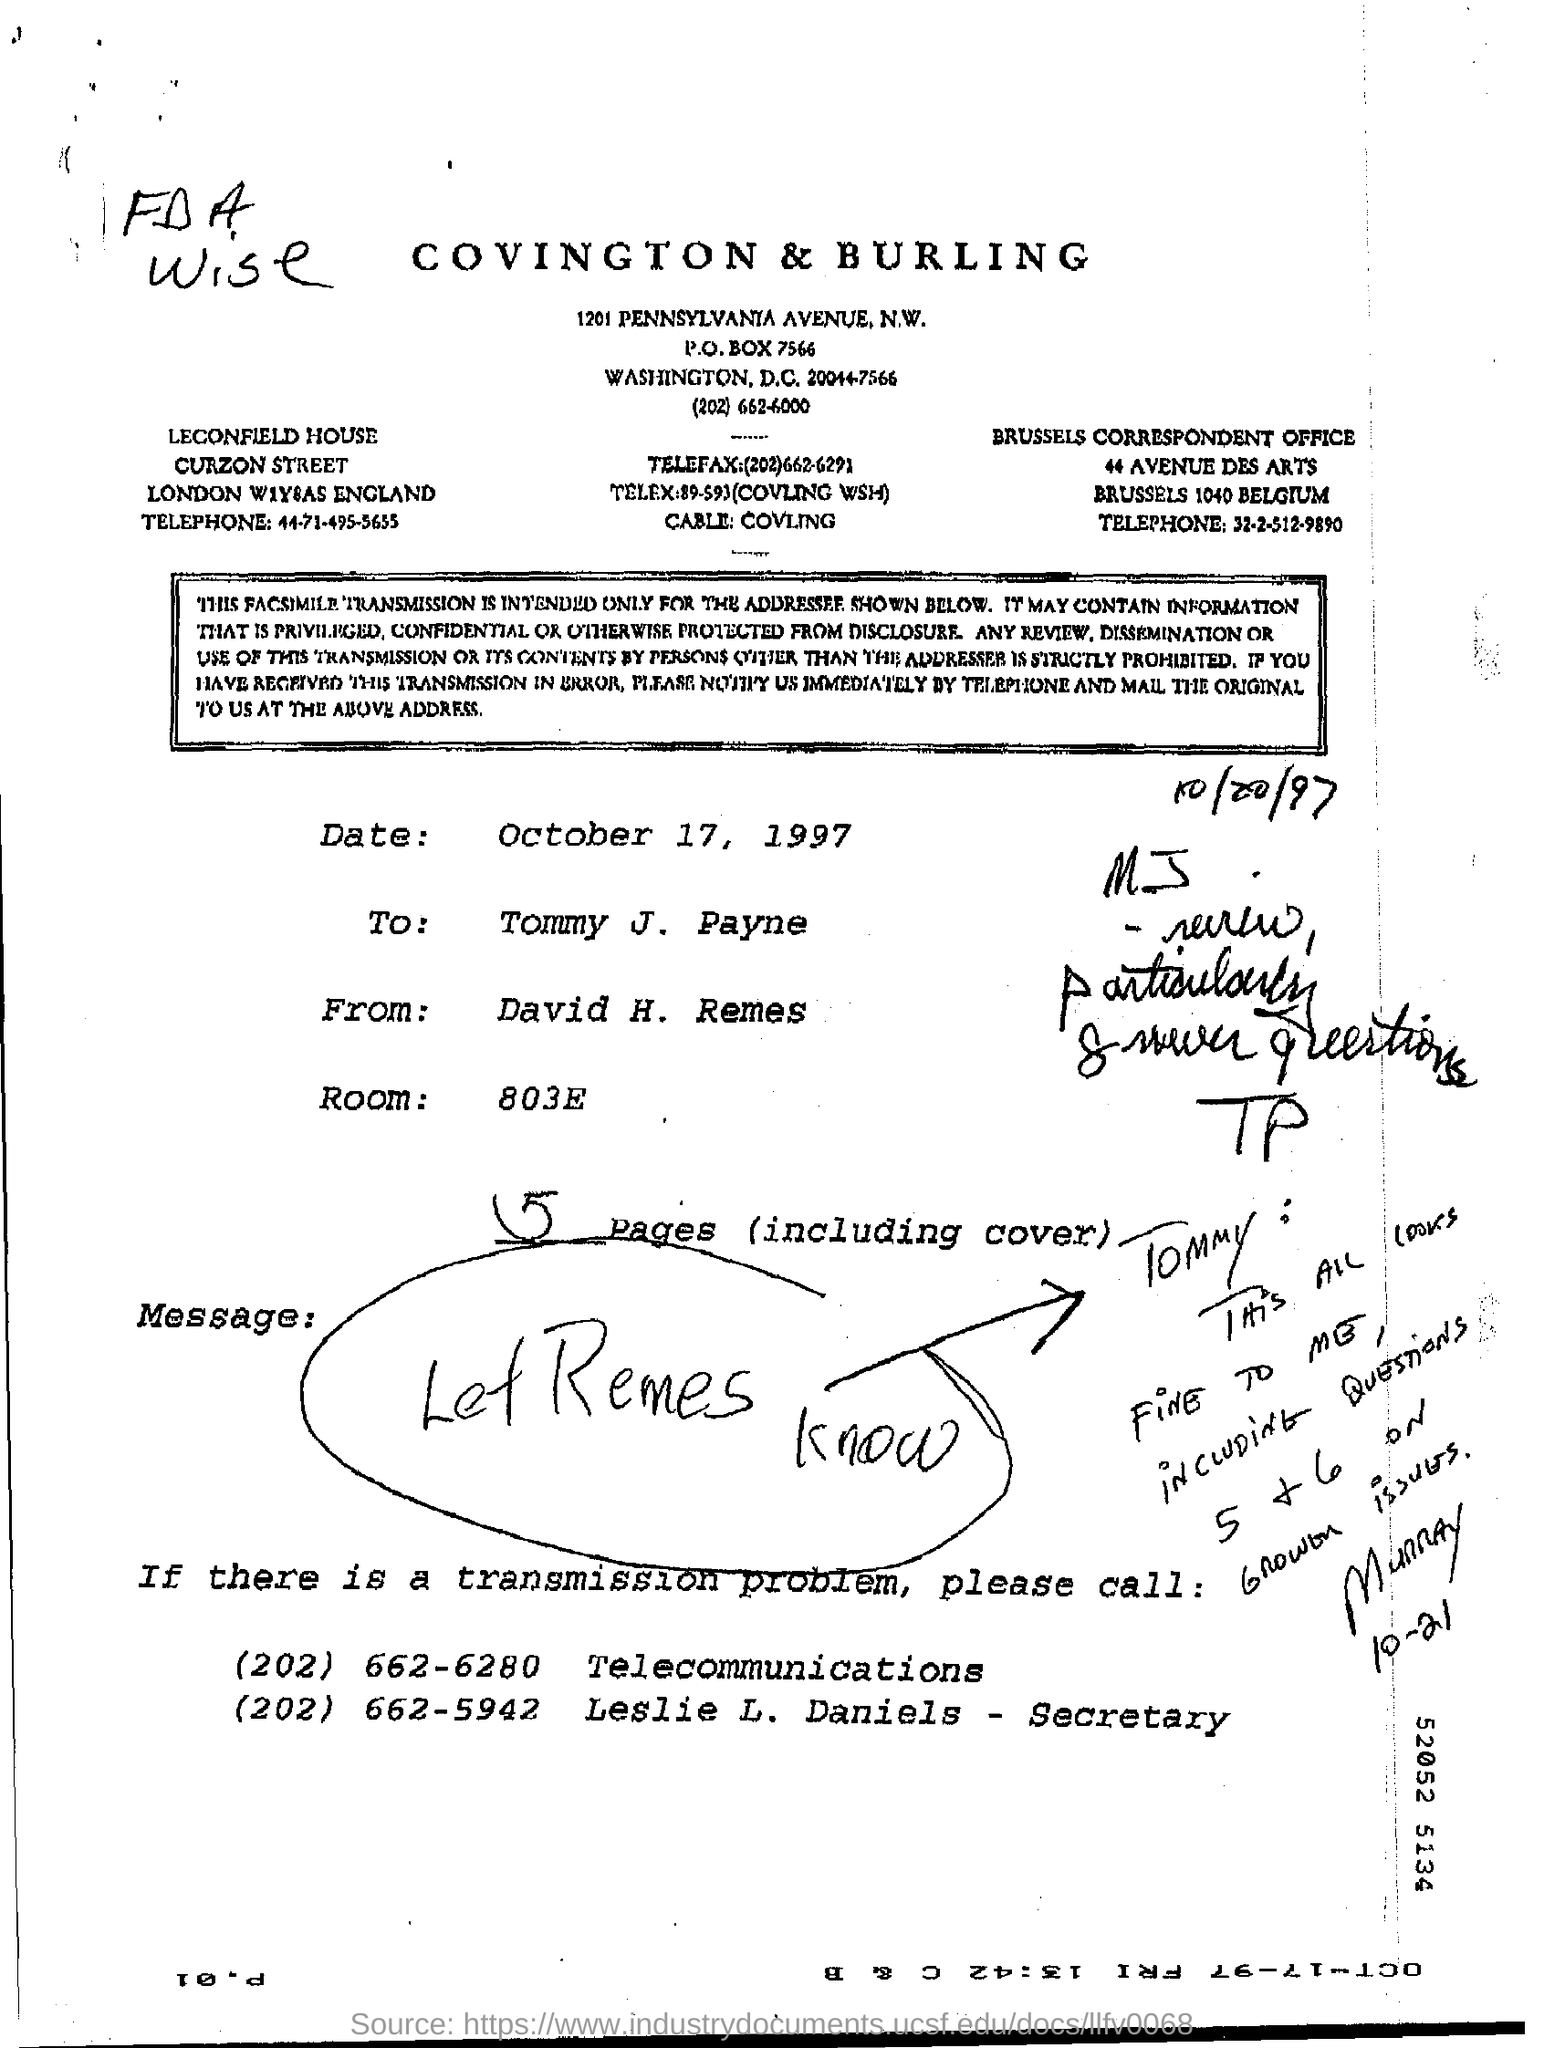Mention a couple of crucial points in this snapshot. There are five pages, including the cover page. The room number is 803E. 